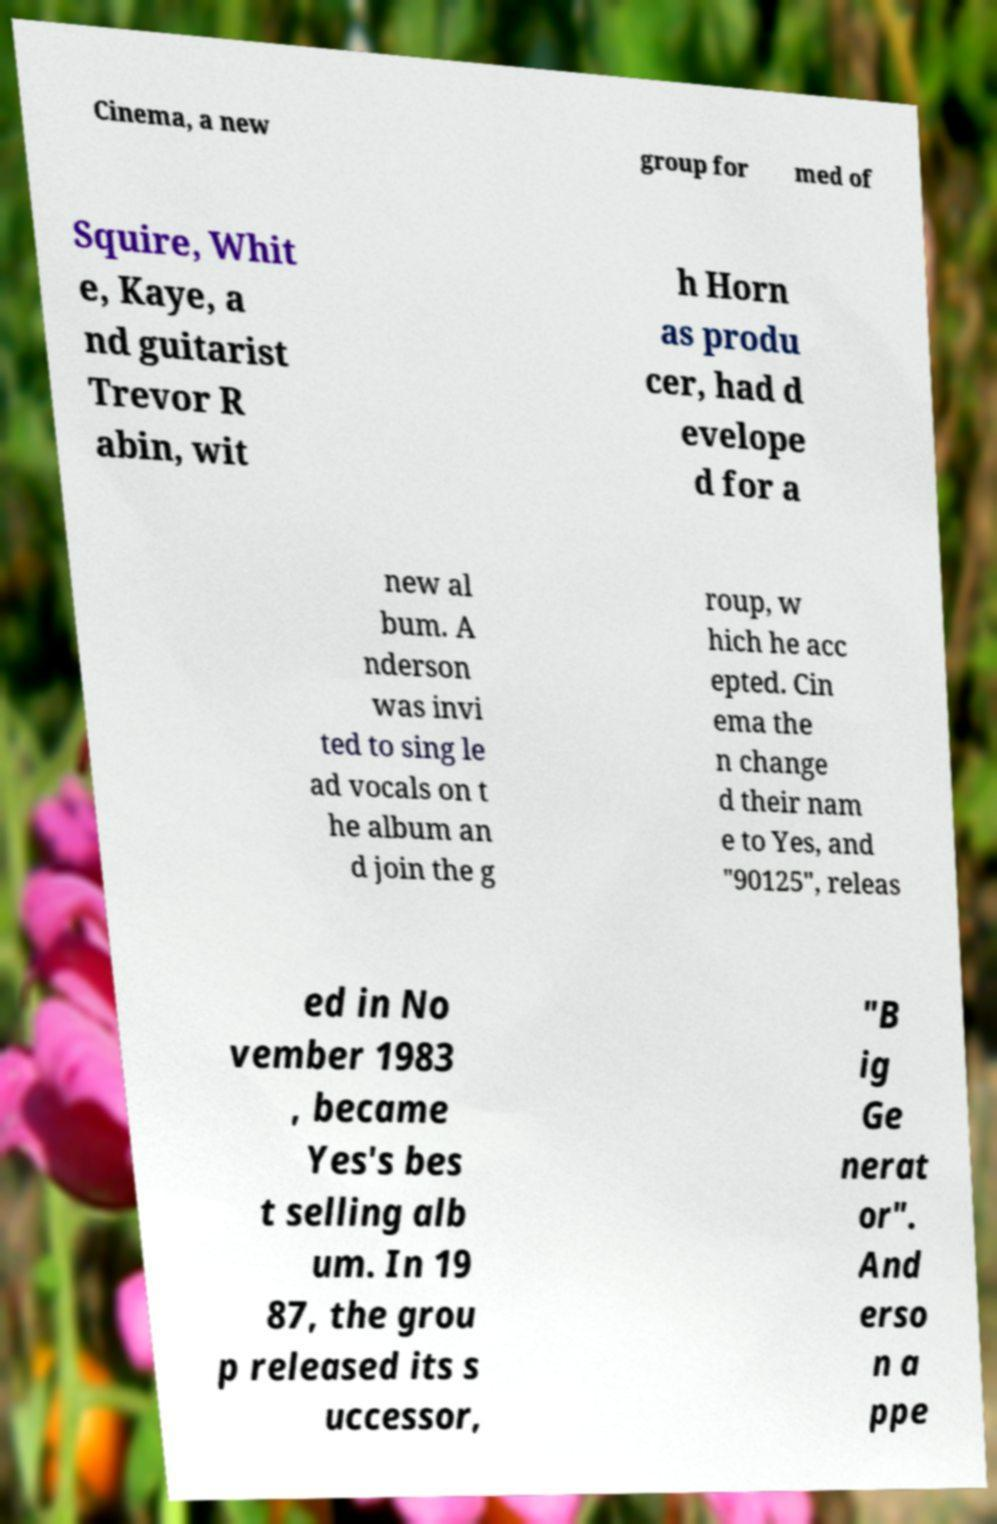Please read and relay the text visible in this image. What does it say? Cinema, a new group for med of Squire, Whit e, Kaye, a nd guitarist Trevor R abin, wit h Horn as produ cer, had d evelope d for a new al bum. A nderson was invi ted to sing le ad vocals on t he album an d join the g roup, w hich he acc epted. Cin ema the n change d their nam e to Yes, and "90125", releas ed in No vember 1983 , became Yes's bes t selling alb um. In 19 87, the grou p released its s uccessor, "B ig Ge nerat or". And erso n a ppe 